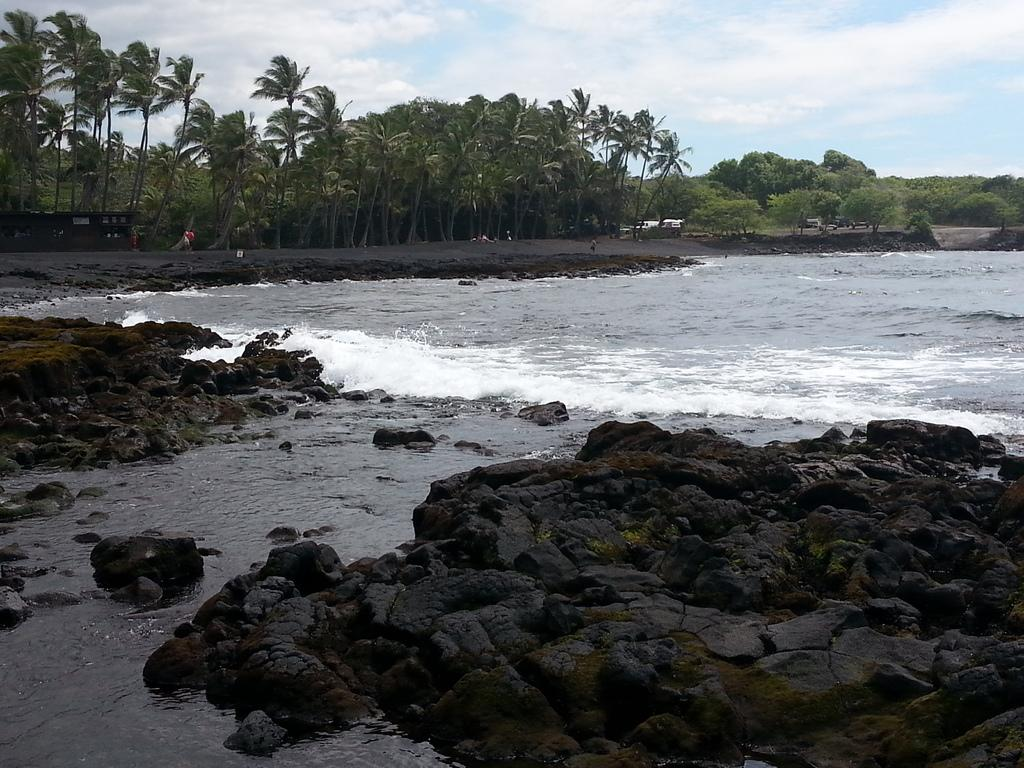What is present in the image that is not solid? There is water in the image. What objects can be seen in the water? There are rocks in the image. What type of trees are visible in the background? There are coconut trees and other trees in the background of the image. What can be seen above the trees and rocks in the image? The sky is visible in the image, and there are clouds in the sky. What type of vegetable is growing on the hill in the image? There is no hill or vegetable present in the image. How many trees are growing on the hill in the image? There is no hill or trees growing on a hill in the image. 